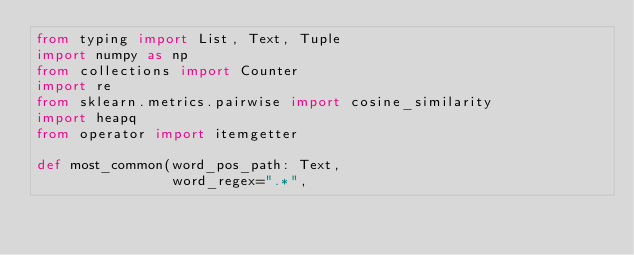<code> <loc_0><loc_0><loc_500><loc_500><_Python_>from typing import List, Text, Tuple
import numpy as np
from collections import Counter
import re
from sklearn.metrics.pairwise import cosine_similarity
import heapq
from operator import itemgetter

def most_common(word_pos_path: Text,
                word_regex=".*",</code> 